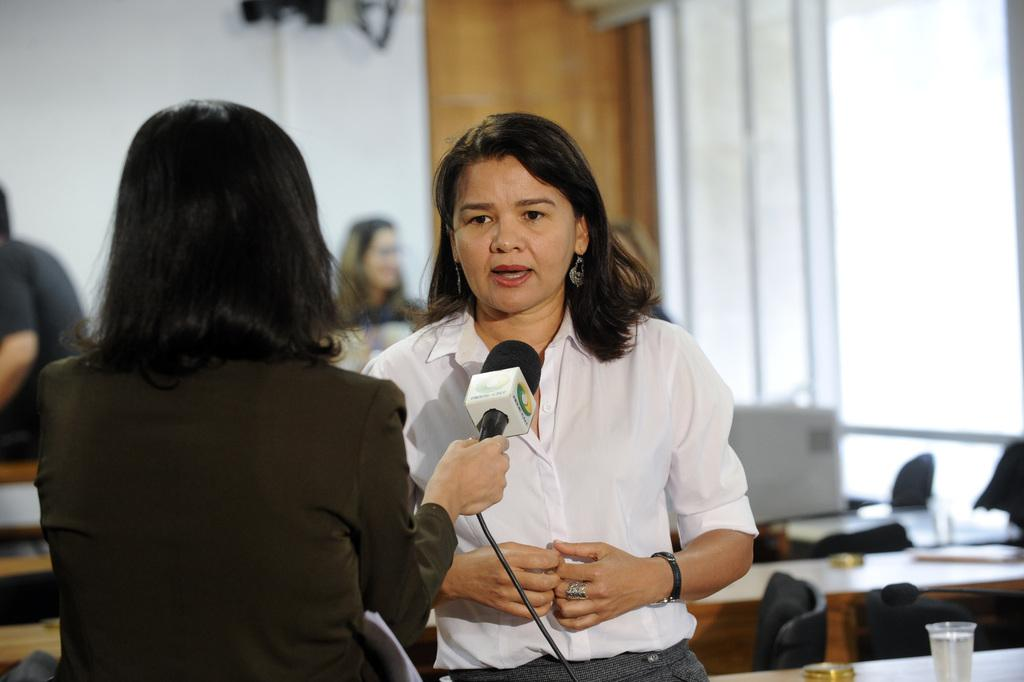How many people are present in the image? There are two women standing in the image. What is one of the women holding? One of the women is holding a microphone. What can be seen in the background of the image? There are tables and chairs visible in the background of the image. What type of polish is being applied to the boundary in the image? There is no boundary or polish present in the image. What effect does the microphone have on the chairs in the image? The microphone does not have any effect on the chairs in the image; it is being held by one of the women. 